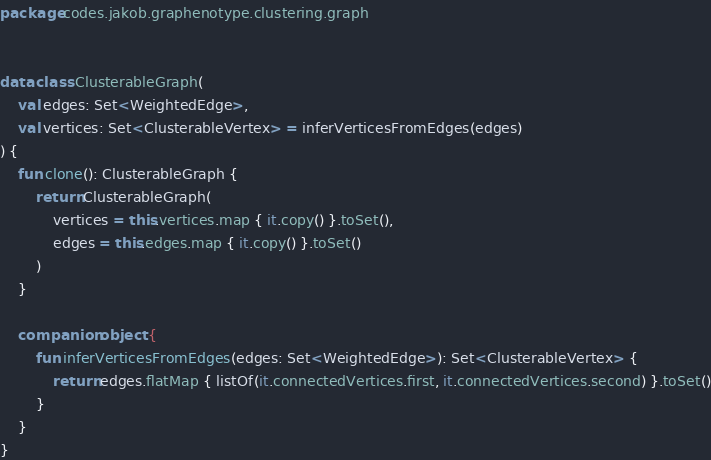<code> <loc_0><loc_0><loc_500><loc_500><_Kotlin_>package codes.jakob.graphenotype.clustering.graph


data class ClusterableGraph(
    val edges: Set<WeightedEdge>,
    val vertices: Set<ClusterableVertex> = inferVerticesFromEdges(edges)
) {
    fun clone(): ClusterableGraph {
        return ClusterableGraph(
            vertices = this.vertices.map { it.copy() }.toSet(),
            edges = this.edges.map { it.copy() }.toSet()
        )
    }

    companion object {
        fun inferVerticesFromEdges(edges: Set<WeightedEdge>): Set<ClusterableVertex> {
            return edges.flatMap { listOf(it.connectedVertices.first, it.connectedVertices.second) }.toSet()
        }
    }
}
</code> 